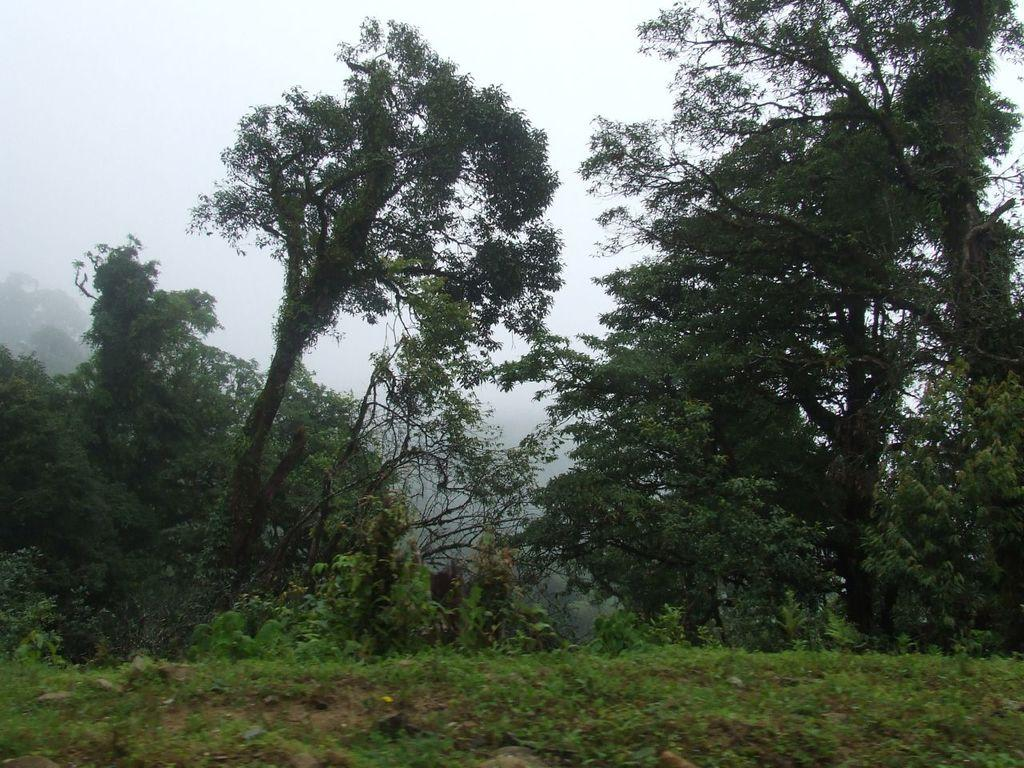What type of vegetation can be seen in the image? There are trees in the image. What is visible at the top of the image? The sky is visible at the top of the image. What is visible at the bottom of the image? The ground is visible at the bottom of the image. How many cats are sitting on the cart in the image? There is no cart or cat present in the image. What type of addition can be seen in the image? There is no addition or mathematical operation present in the image. 